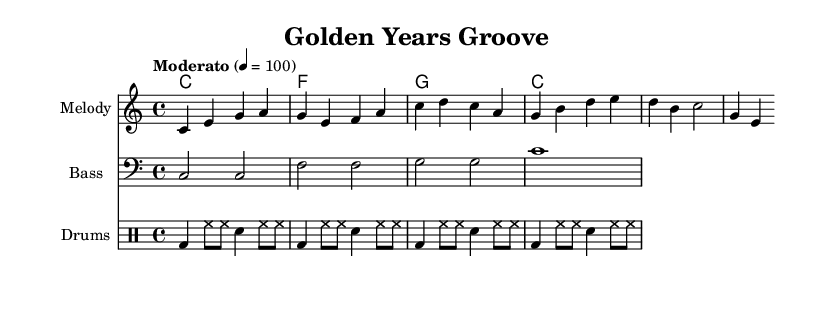What is the key signature of this music? The key signature indicates that there are no sharps or flats, placing it in the key of C major. This can be observed at the beginning of the staff where the key signature is notated.
Answer: C major What is the time signature of this music? The time signature is shown at the beginning of the music, which is 4/4. This signifies that there are four beats in each measure and the quarter note gets one beat.
Answer: 4/4 What is the tempo marking of this piece? The tempo marking is specified as "Moderato" followed by "4 = 100," which indicates the piece should be played at a moderate speed of 100 beats per minute.
Answer: Moderato How many measures does the melody section contain? Counting the measures in the melody staff, there are a total of 4 measures. Each group of notes separated by vertical lines indicates a measure.
Answer: 4 What is the rhythmic pattern of the drums? The drum part shows a repetitive rhythmic pattern where kick drum (bd) is on beats 1 and snare (sn) on beats 3, while hi-hat (hh) plays on the off-beats, forming a steady groove.
Answer: Steady groove What is the relationship between the harmony and the bass lines? The harmony typically determines the chord being played while the bass line reinforces the root note of each chord, creating a supportive foundation. For example, where harmonies state C, the bass plays C2, providing a solid underpinning.
Answer: Supportive foundation What genre does this piece fall under? The piece is characterized by its electronic instrumentation, rhythm, and sound style commonly found in uplifting electronic music, aimed at gentle exercise routines.
Answer: Electronic 